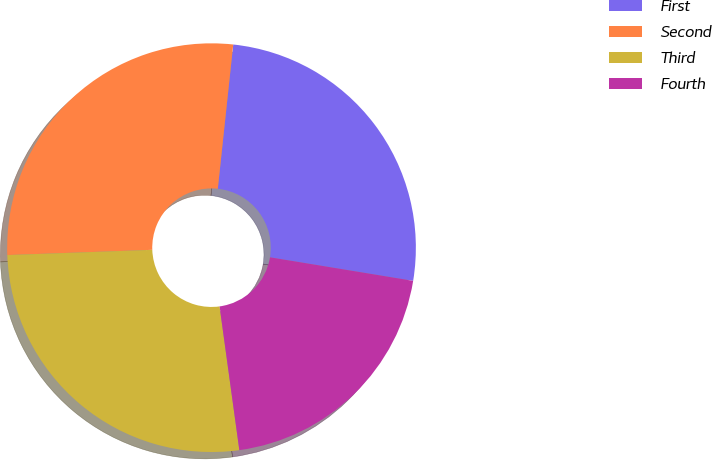Convert chart. <chart><loc_0><loc_0><loc_500><loc_500><pie_chart><fcel>First<fcel>Second<fcel>Third<fcel>Fourth<nl><fcel>25.9%<fcel>27.27%<fcel>26.6%<fcel>20.23%<nl></chart> 